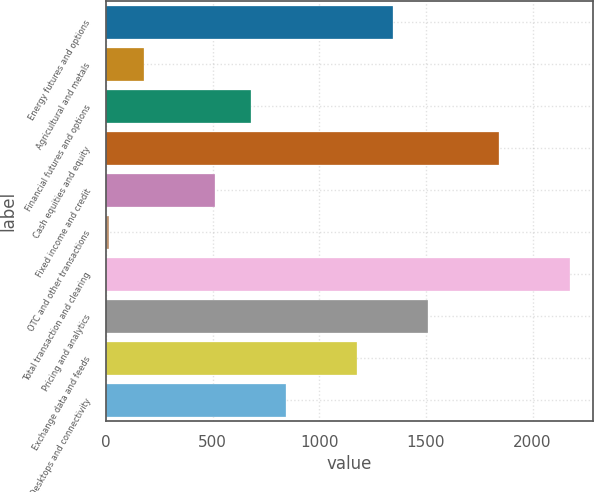Convert chart. <chart><loc_0><loc_0><loc_500><loc_500><bar_chart><fcel>Energy futures and options<fcel>Agricultural and metals<fcel>Financial futures and options<fcel>Cash equities and equity<fcel>Fixed income and credit<fcel>OTC and other transactions<fcel>Total transaction and clearing<fcel>Pricing and analytics<fcel>Exchange data and feeds<fcel>Desktops and connectivity<nl><fcel>1344.2<fcel>179.4<fcel>678.6<fcel>1843.4<fcel>512.2<fcel>13<fcel>2176.2<fcel>1510.6<fcel>1177.8<fcel>845<nl></chart> 